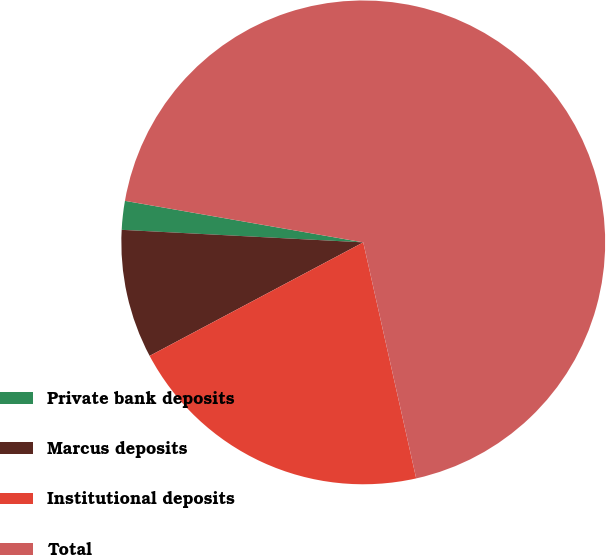<chart> <loc_0><loc_0><loc_500><loc_500><pie_chart><fcel>Private bank deposits<fcel>Marcus deposits<fcel>Institutional deposits<fcel>Total<nl><fcel>1.92%<fcel>8.6%<fcel>20.74%<fcel>68.75%<nl></chart> 